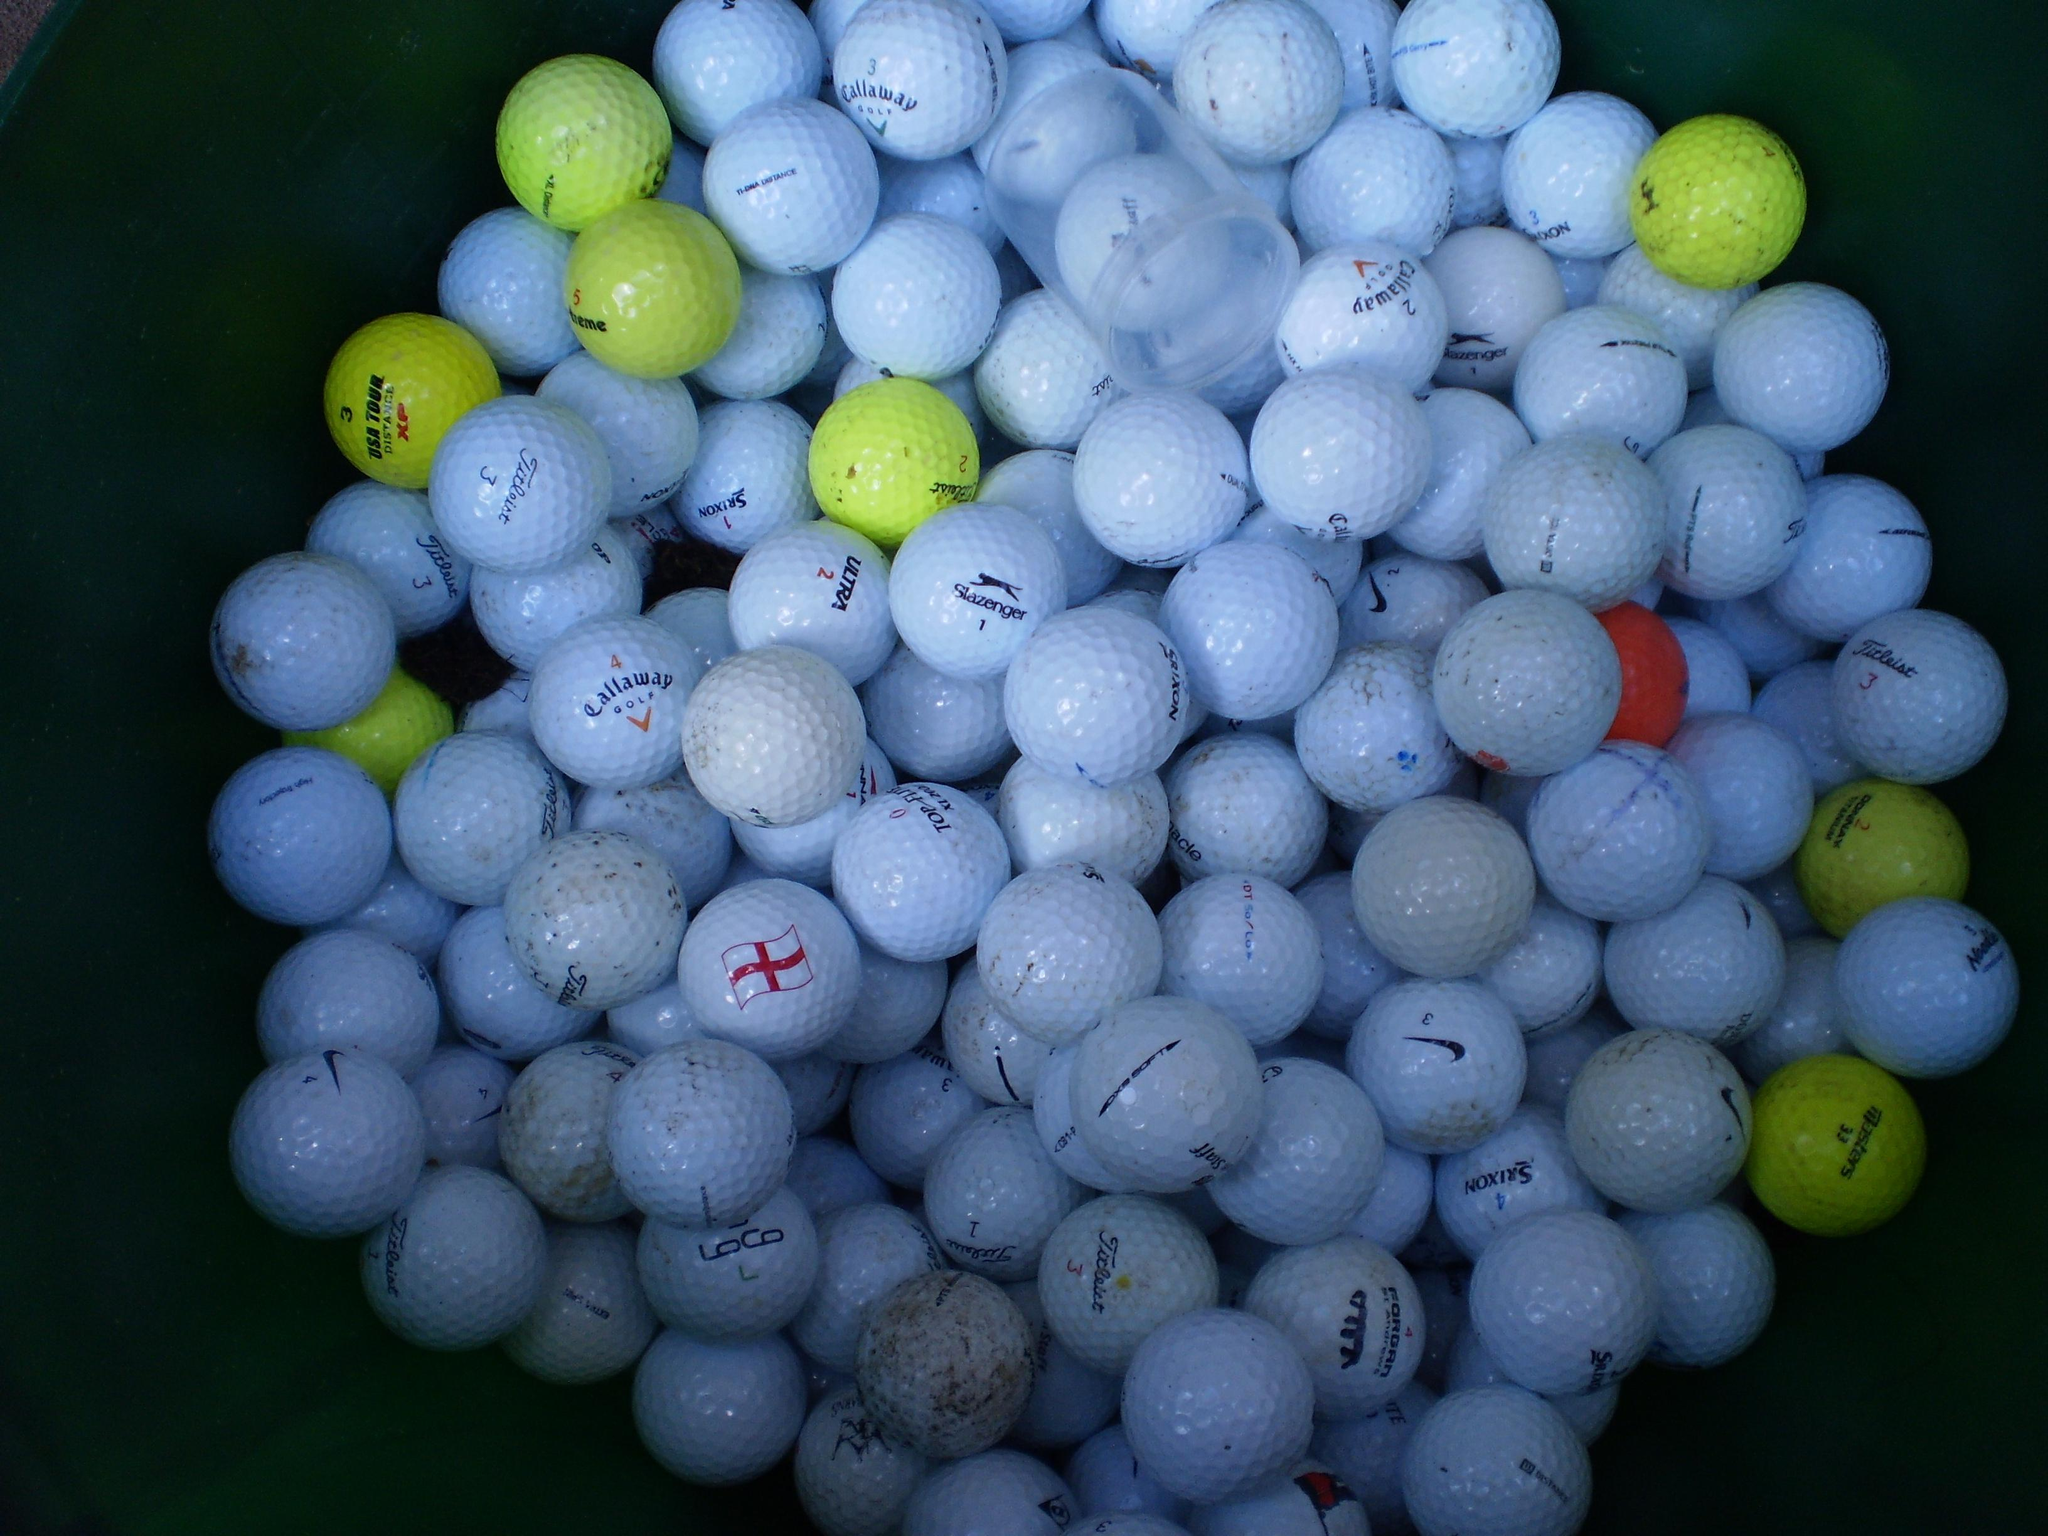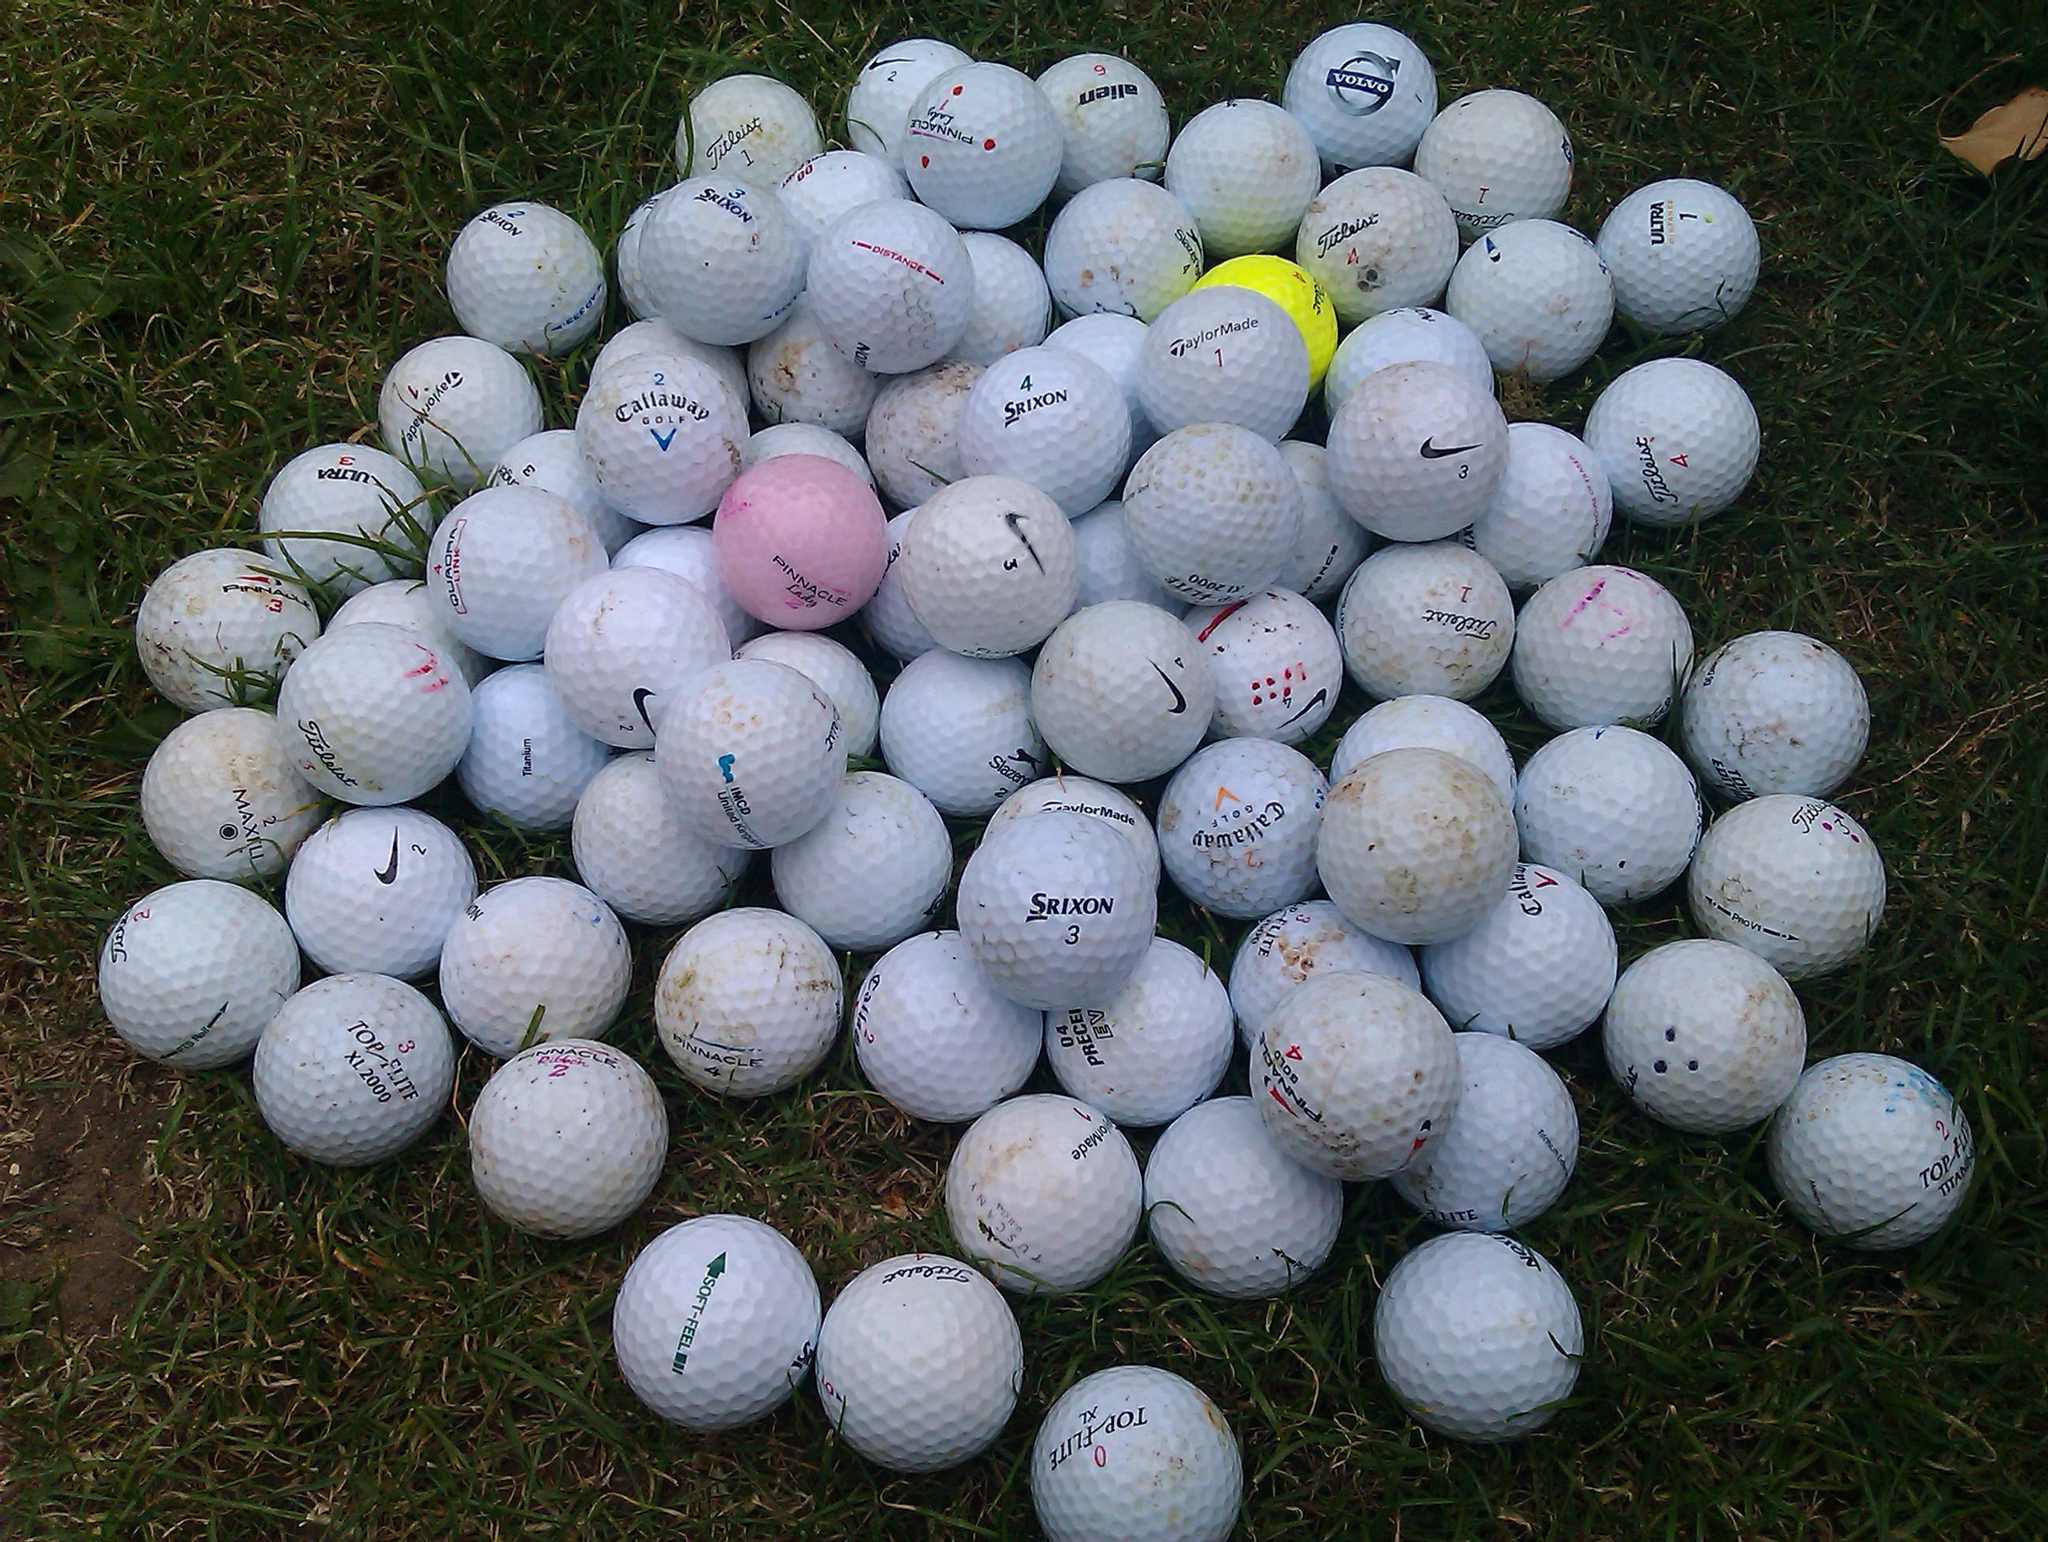The first image is the image on the left, the second image is the image on the right. Evaluate the accuracy of this statement regarding the images: "At least one pink golf ball can be seen in a large pile of mostly white golf balls in one image.". Is it true? Answer yes or no. Yes. The first image is the image on the left, the second image is the image on the right. For the images shown, is this caption "At least one image shows white golf balls in a mesh-type green basket." true? Answer yes or no. No. 